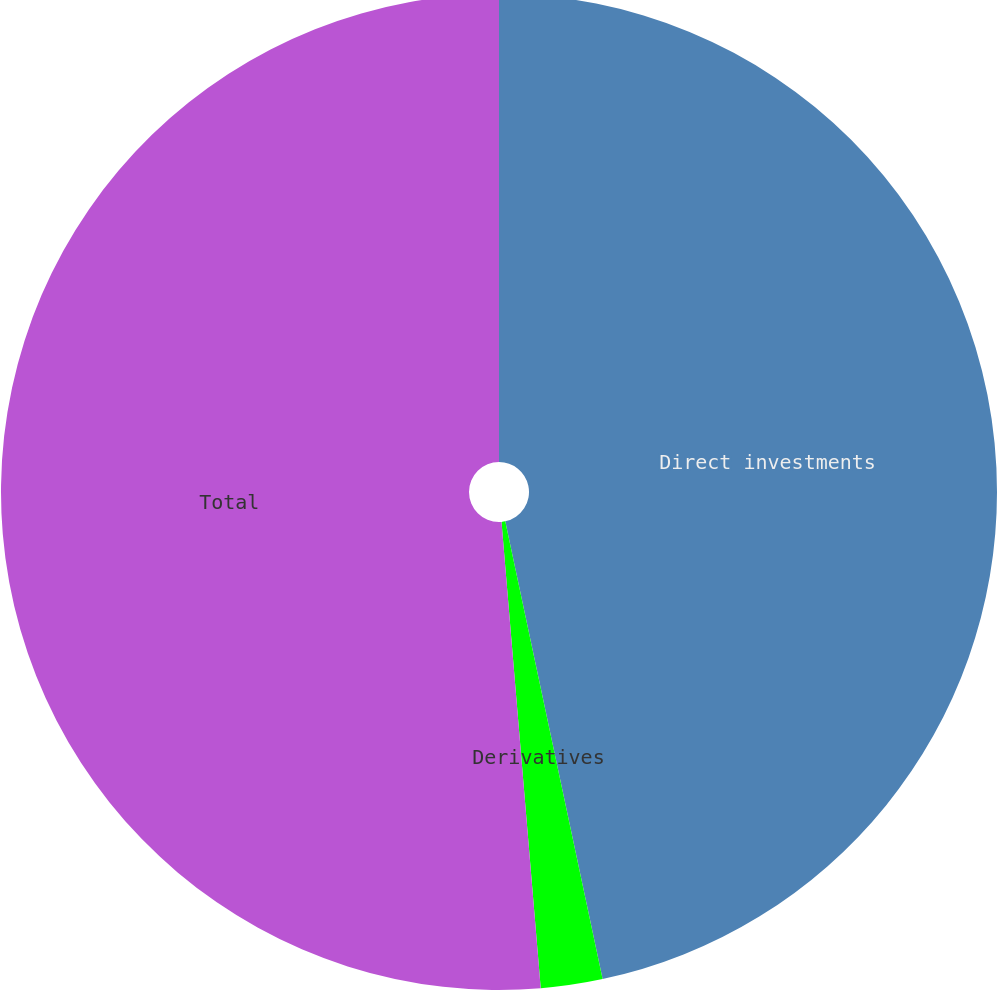Convert chart. <chart><loc_0><loc_0><loc_500><loc_500><pie_chart><fcel>Direct investments<fcel>Derivatives<fcel>Total<nl><fcel>46.66%<fcel>2.0%<fcel>51.33%<nl></chart> 